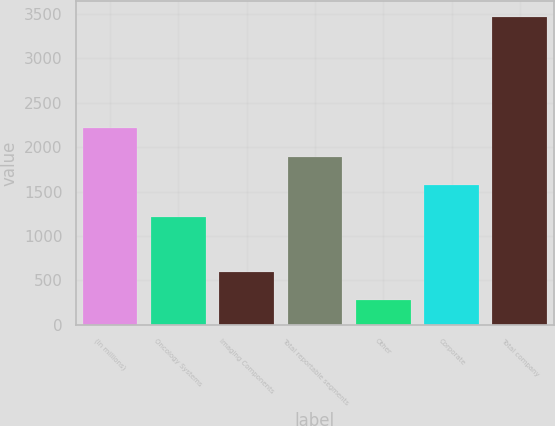Convert chart to OTSL. <chart><loc_0><loc_0><loc_500><loc_500><bar_chart><fcel>(In millions)<fcel>Oncology Systems<fcel>Imaging Components<fcel>Total reportable segments<fcel>Other<fcel>Corporate<fcel>Total company<nl><fcel>2212.98<fcel>1217<fcel>597.14<fcel>1893.94<fcel>278.1<fcel>1574.9<fcel>3468.5<nl></chart> 